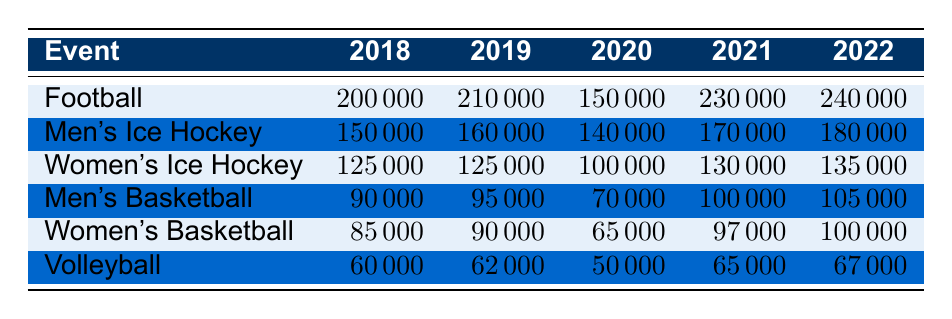What was the revenue from Football in 2021? The table shows the revenue for the Football event in the year 2021 as 230000.
Answer: 230000 Which women's sport generated the highest revenue in 2022? In 2022, the Women's Basketball event generated the highest revenue at 100000 compared to Women's Ice Hockey which was at 135000. So the event to consider is Women's Ice Hockey.
Answer: Women's Ice Hockey What was the total revenue from Men's Ice Hockey across all years listed? To find the total revenue from Men's Ice Hockey, we add the revenues for each year: (150000 + 160000 + 140000 + 170000 + 180000) = 900000.
Answer: 900000 In which year did Men's Basketball show the lowest revenue? From the table, the revenue for Men's Basketball is 90000 in 2018, 95000 in 2019, 70000 in 2020, 100000 in 2021, and 105000 in 2022. The lowest revenue is clearly in the year 2020 at 70000.
Answer: 2020 Is it true that Volleyball earned more revenue than Women's Basketball in 2020? In 2020, Volleyball earned 50000 while Women's Basketball earned 65000. Therefore, Volleyball did not earn more than Women's Basketball in that year, so the statement is false.
Answer: No 